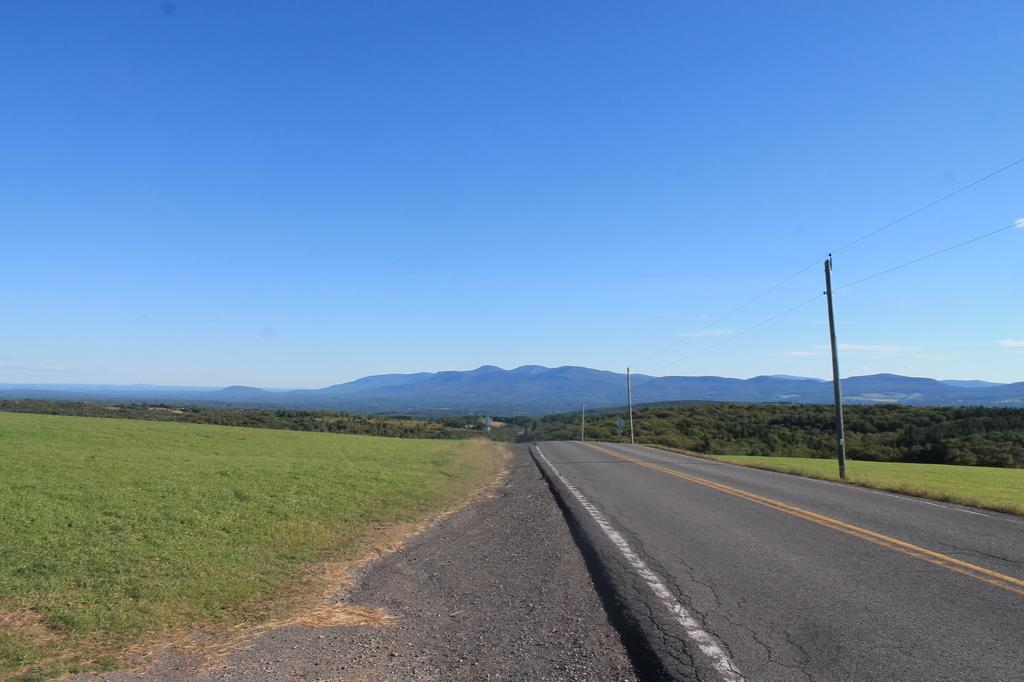What is the main feature of the image? There is a road in the image. What type of terrain is visible along the road? There is grass on the ground. What else can be seen in the image besides the road and grass? There are poles and wires in the image. What can be seen in the distance in the image? There are hills in the background of the image, and the sky is visible as well. What type of polish is being applied to the net in the image? There is no net or polish present in the image. 